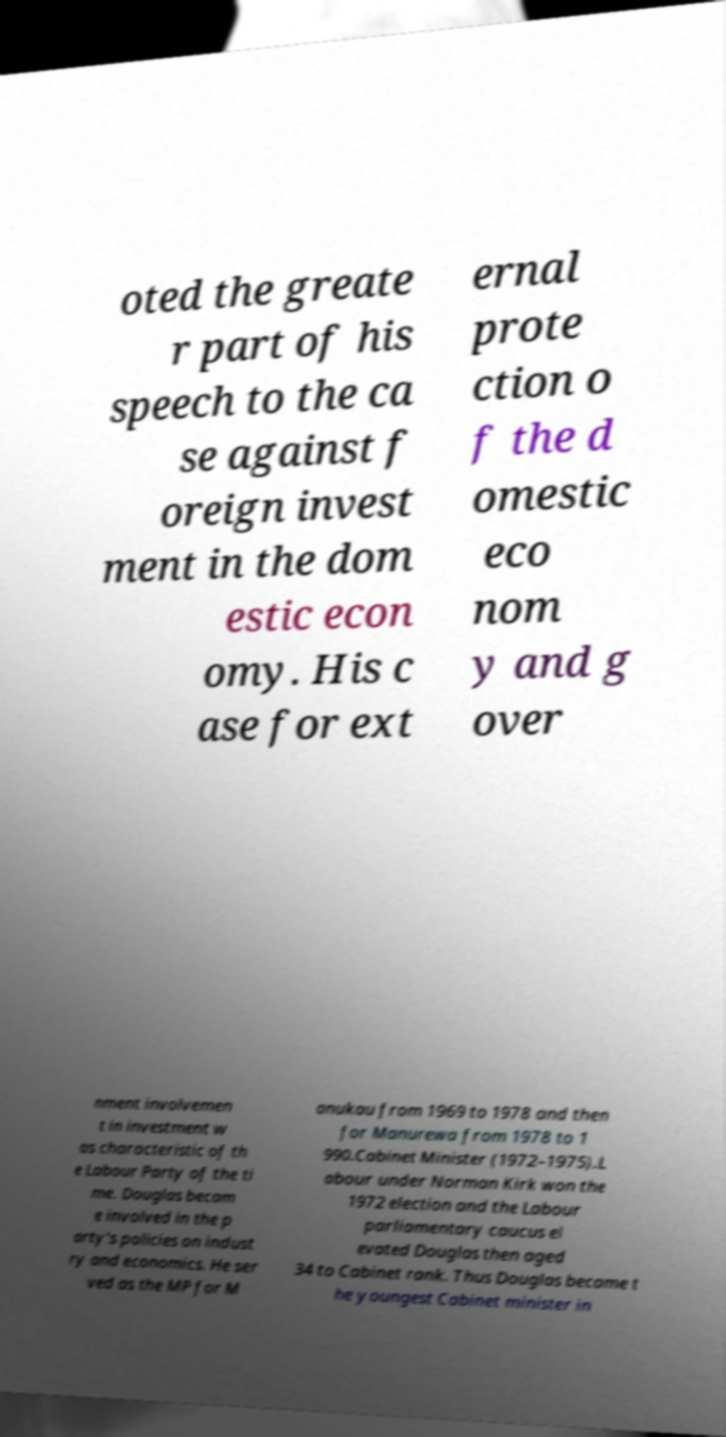Please identify and transcribe the text found in this image. oted the greate r part of his speech to the ca se against f oreign invest ment in the dom estic econ omy. His c ase for ext ernal prote ction o f the d omestic eco nom y and g over nment involvemen t in investment w as characteristic of th e Labour Party of the ti me. Douglas becam e involved in the p arty's policies on indust ry and economics. He ser ved as the MP for M anukau from 1969 to 1978 and then for Manurewa from 1978 to 1 990.Cabinet Minister (1972–1975).L abour under Norman Kirk won the 1972 election and the Labour parliamentary caucus el evated Douglas then aged 34 to Cabinet rank. Thus Douglas became t he youngest Cabinet minister in 